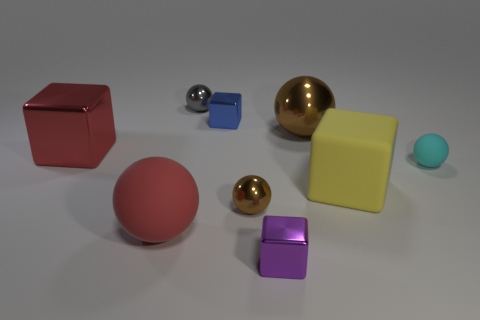Is the gray object made of the same material as the tiny cyan thing?
Your response must be concise. No. How many cubes are big red shiny objects or tiny blue things?
Your answer should be very brief. 2. There is a big object that is the same material as the large red cube; what color is it?
Offer a terse response. Brown. Are there fewer small gray spheres than matte spheres?
Give a very brief answer. Yes. There is a large metal object on the right side of the red rubber object; is it the same shape as the big rubber thing right of the small purple shiny object?
Make the answer very short. No. What number of things are either big red matte cylinders or rubber spheres?
Your answer should be compact. 2. There is another metallic ball that is the same size as the gray ball; what is its color?
Give a very brief answer. Brown. There is a big red object that is behind the big red rubber thing; how many big matte spheres are to the left of it?
Offer a very short reply. 0. How many matte objects are behind the large red sphere and on the left side of the small cyan object?
Ensure brevity in your answer.  1. What number of objects are shiny objects that are behind the big brown ball or small metal balls right of the tiny blue shiny thing?
Offer a very short reply. 3. 